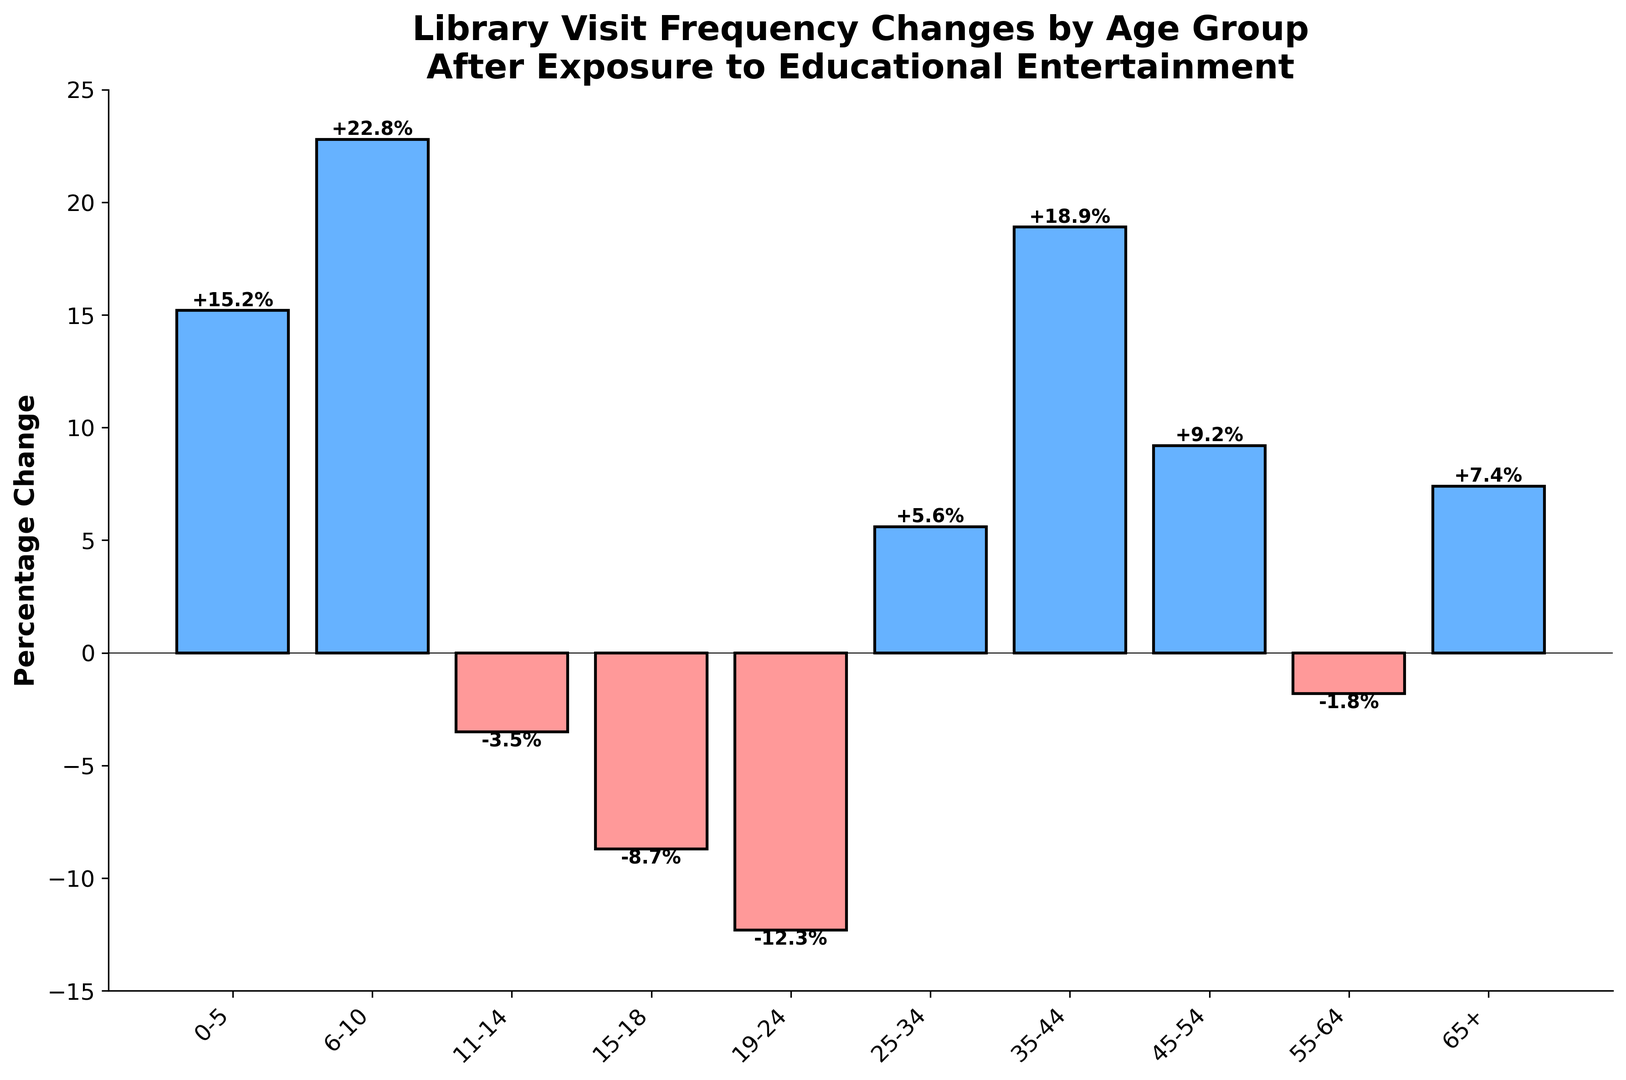What age group shows the most significant increase in library visits after exposure? The bar for the age group 6-10 is the tallest in the positive direction, indicating the highest percentage change.
Answer: 6-10 Which age group experienced the largest decline in library visits? The bar for the age group 19-24 is the tallest in the negative direction, indicating the largest percentage decline.
Answer: 19-24 How does the percentage change for the age group 35-44 compare with the age group 25-34? The bar for age group 35-44 is taller (more positive) than the bar for age group 25-34.
Answer: 35-44 is higher Calculate the average percentage change for all age groups. Sum all percentage changes and divide by the number of age groups: (15.2 + 22.8 + (-3.5) + (-8.7) + (-12.3) + 5.6 + 18.9 + 9.2 + (-1.8) + 7.4) / 10 = 5.28
Answer: 5.28% Are there more age groups with positive changes or negative changes in library visits? Count the number of bars in the positive and negative sides. There are 6 positive and 4 negative bars.
Answer: More positive Which age group has a percentage change closest to zero? The bar for the age group 55-64 is closest to the zero line with a change of -1.8%.
Answer: 55-64 What is the total percentage change for age groups below 15 years old? Sum the percentages for 0-5, 6-10, and 11-14 age groups: 15.2 + 22.8 + (-3.5) = 34.5
Answer: 34.5% What visual indications help identify age groups with negative changes? The bars for negative changes are colored red compared to those colored blue for positive changes.
Answer: Colored red Compare the change in library visits between the youngest and the oldest age groups. The percentage change for 0-5 is 15.2%, while for 65+ it is 7.4%. The youngest group has a higher positive change.
Answer: 0-5 is higher What is the difference in percentage points between the age group 6-10 and 19-24? Subtract the percentage change of 19-24 from 6-10: 22.8 - (-12.3) = 35.1 percentage points
Answer: 35.1 percentage points 